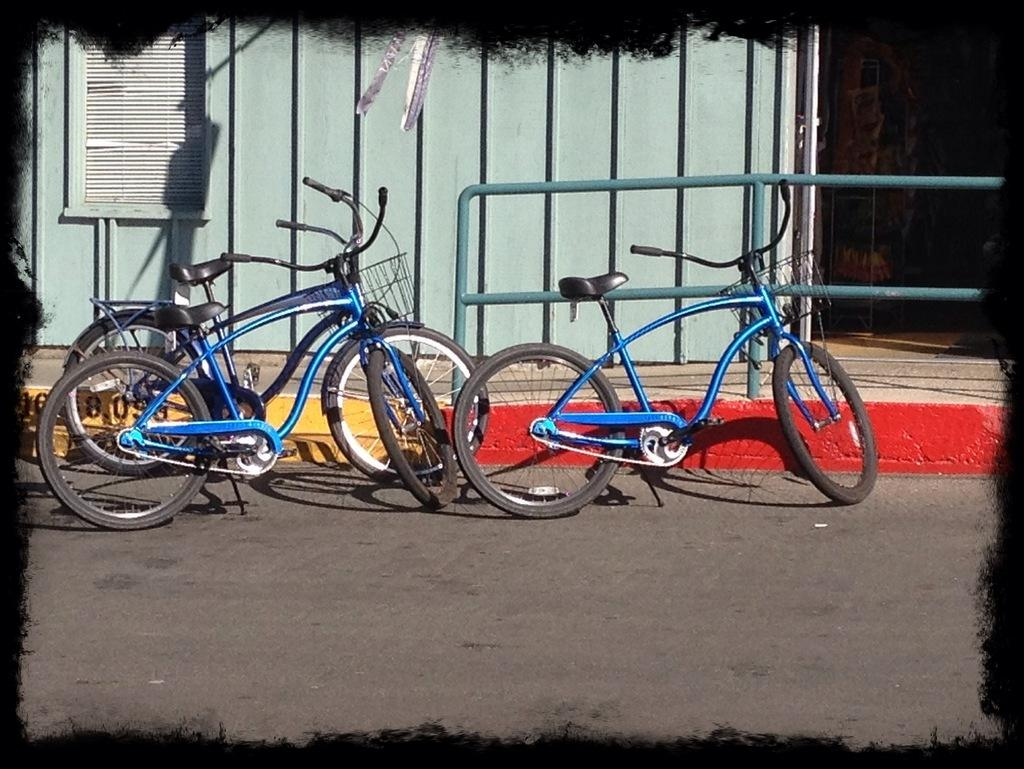What is the main subject in the center of the image? There are cycles in the center of the image. What can be seen on the right side of the image? There is a railing on the right side of the image. What is visible in the background of the image? There is a building and a window in the background of the image. What is visible at the bottom of the image? There is a road visible at the bottom of the image. How many crates are stacked on the cycles in the image? There are no crates present in the image; it features cycles and other elements mentioned in the conversation. 